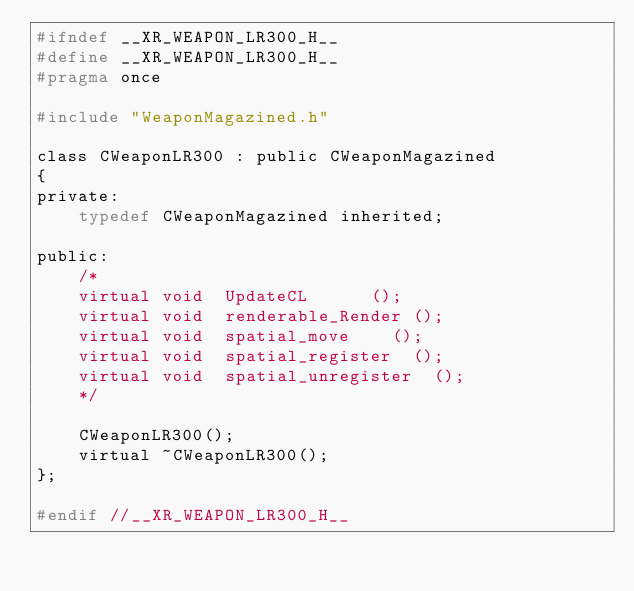Convert code to text. <code><loc_0><loc_0><loc_500><loc_500><_C_>#ifndef __XR_WEAPON_LR300_H__
#define __XR_WEAPON_LR300_H__
#pragma once

#include "WeaponMagazined.h"

class CWeaponLR300 : public CWeaponMagazined
{
private:
    typedef CWeaponMagazined inherited;

public:
    /*
    virtual	void	UpdateCL			();
    virtual void	renderable_Render	();
    virtual void	spatial_move		();
    virtual void	spatial_register	();
    virtual void	spatial_unregister	();
    */

    CWeaponLR300();
    virtual ~CWeaponLR300();
};

#endif //__XR_WEAPON_LR300_H__
</code> 